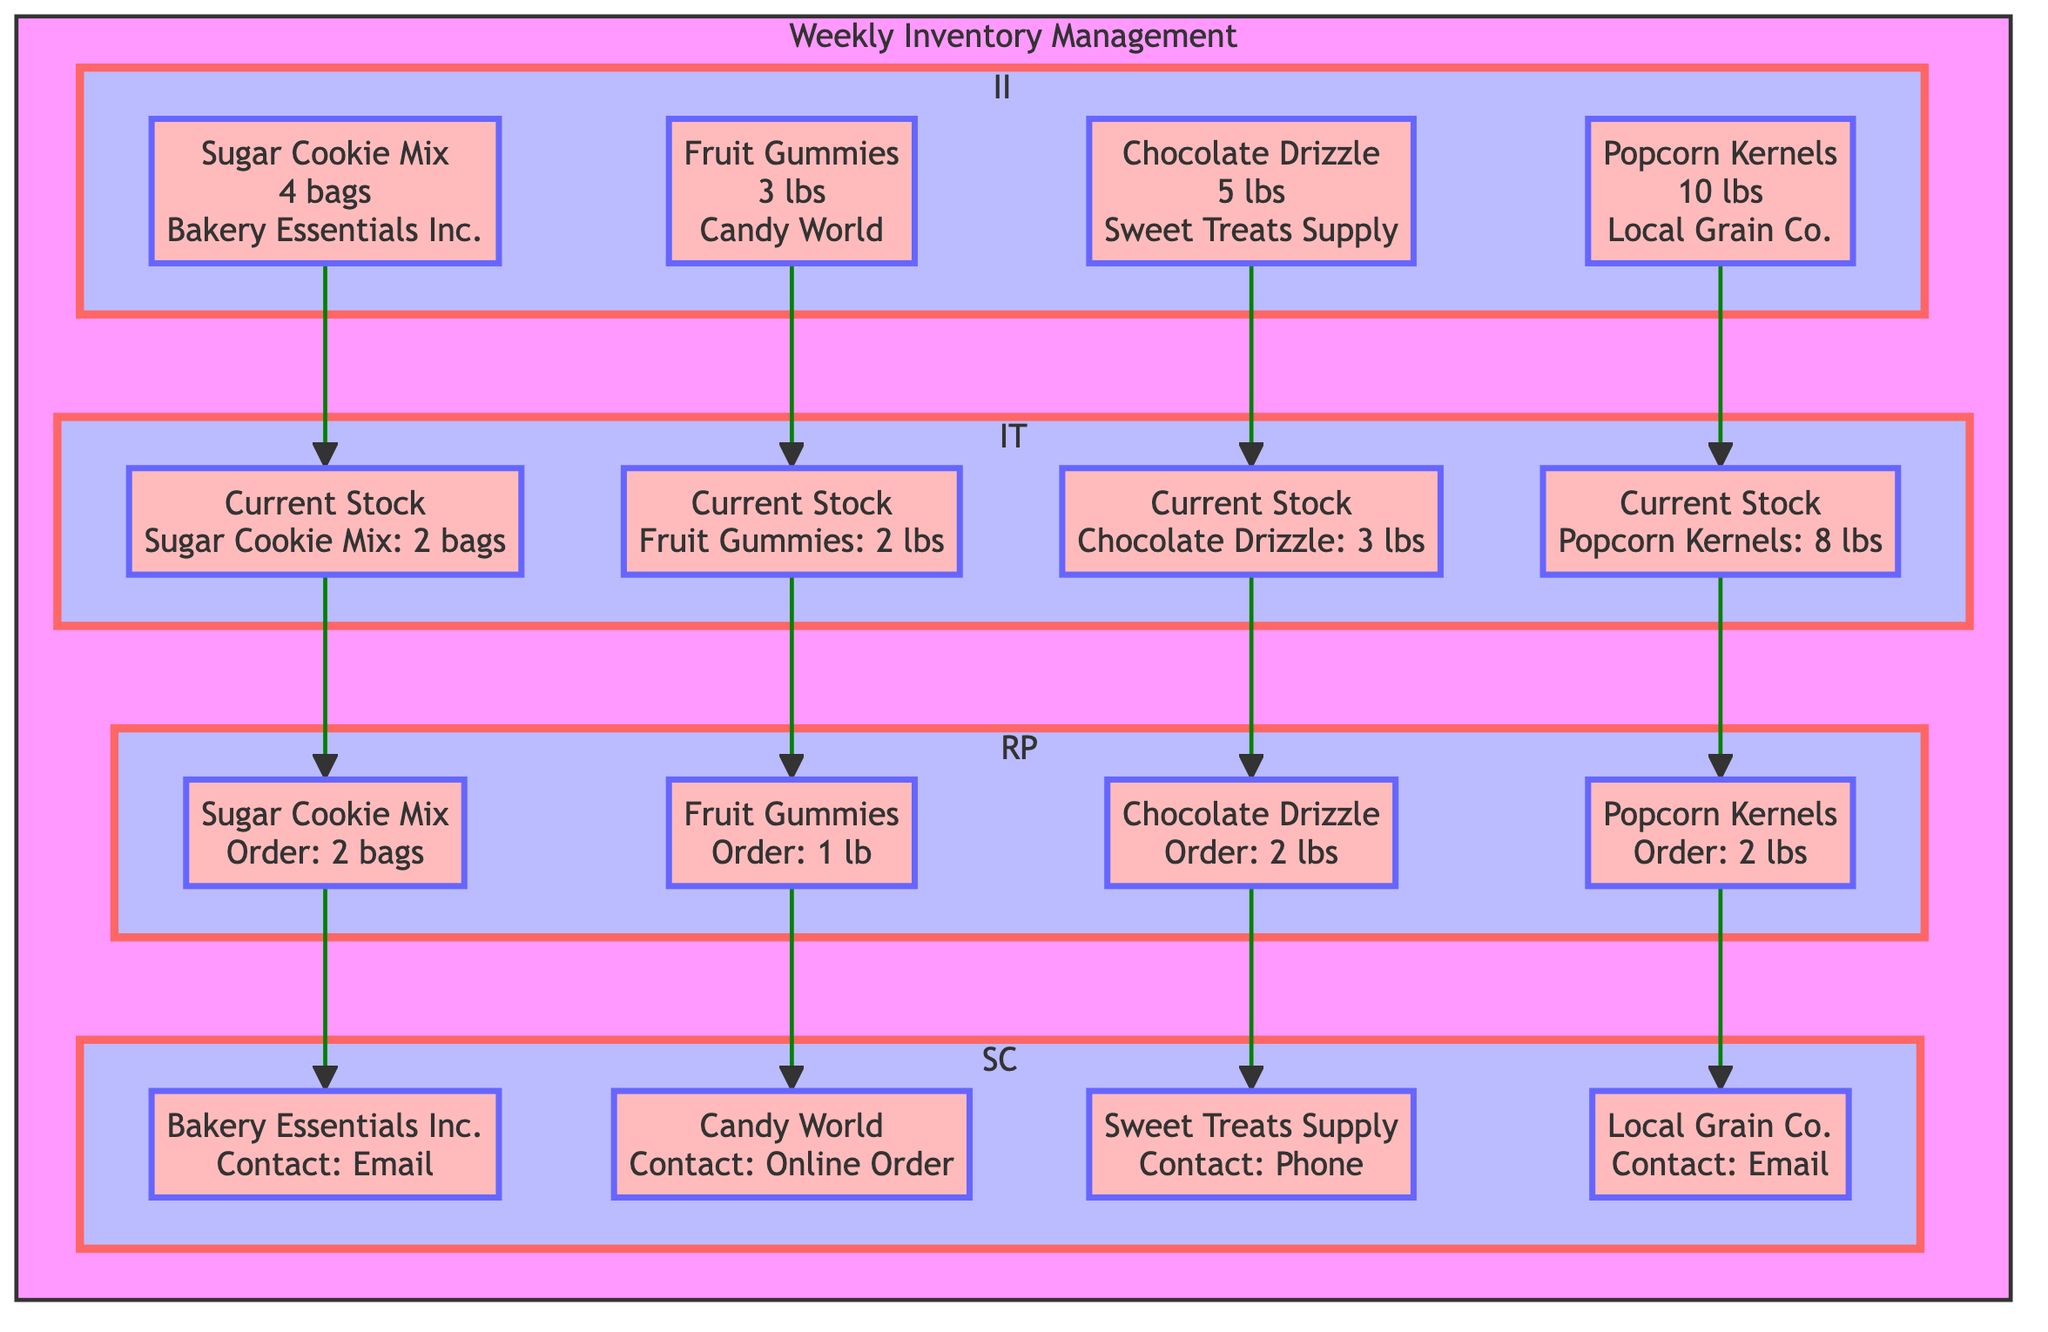What is the quantity of Chocolate Drizzle needed for snacks? The diagram states that the quantity of Chocolate Drizzle needed for the themed snacks is 5 lbs, as identified in the Ingredient Identification section.
Answer: 5 lbs Who is the supplier for Sugar Cookie Mix? In the Ingredient Identification section of the diagram, it is mentioned that the supplier for Sugar Cookie Mix is Bakery Essentials Inc.
Answer: Bakery Essentials Inc What is the current stock of Fruit Gummies? The diagram indicates that the current stock for Fruit Gummies is 2 lbs, as seen in the Inventory Tracking section.
Answer: 2 lbs How many bags of Sugar Cookie Mix are ordered? Looking at the Restock Planning section, the quantity ordered for Sugar Cookie Mix is stated as 2 bags.
Answer: 2 bags What method is used to contact Sweet Treats Supply? In the Supplier Communication section, it is specified that Sweet Treats Supply is contacted by Phone.
Answer: Phone What is the order quantity for Popcorn Kernels? Referring to the Restock Planning section, the order quantity for Popcorn Kernels is indicated as 2 lbs.
Answer: 2 lbs How many total different ingredients are listed in the diagram? The diagram presents a total of 4 different ingredients (Popcorn Kernels, Chocolate Drizzle, Fruit Gummies, and Sugar Cookie Mix) in the Ingredient Identification section.
Answer: 4 Which ingredient has the highest current stock level? The Inventory Tracking section shows that Popcorn Kernels have the highest current stock level at 8 lbs compared to the other ingredients.
Answer: 8 lbs What is the first step in the Weekly Inventory Management process? The top-level of the flow chart indicates that the first step is Ingredient Identification, which is the initial process before moving to inventory tracking and other steps.
Answer: Ingredient Identification 